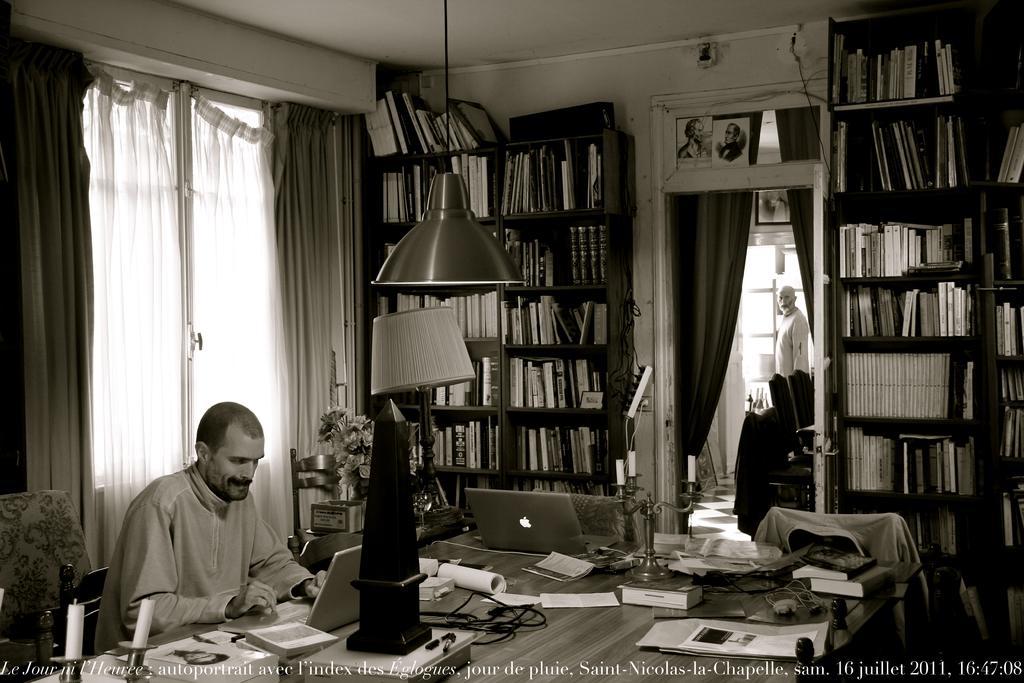Could you give a brief overview of what you see in this image? In this image I can see a man sitting on a chair working on his laptop. This is a room which consists of book shelf were i can see a lot of books which are placed in a rack. And here is a lamp which is changed through the ceiling and this is the table where laptops,books,candle stand and some papers were placed on the table. I can see a flower vase at the background. And here there is a curtain hanged,and behind that i can see a man standing in the other room. And this is the another bookshelf where books were placed. And I think this is a kind of jerkin which was hanged on the chair. This is a window with curtains covered up and i can see another candle stand holding candles which is placed on above the table. 